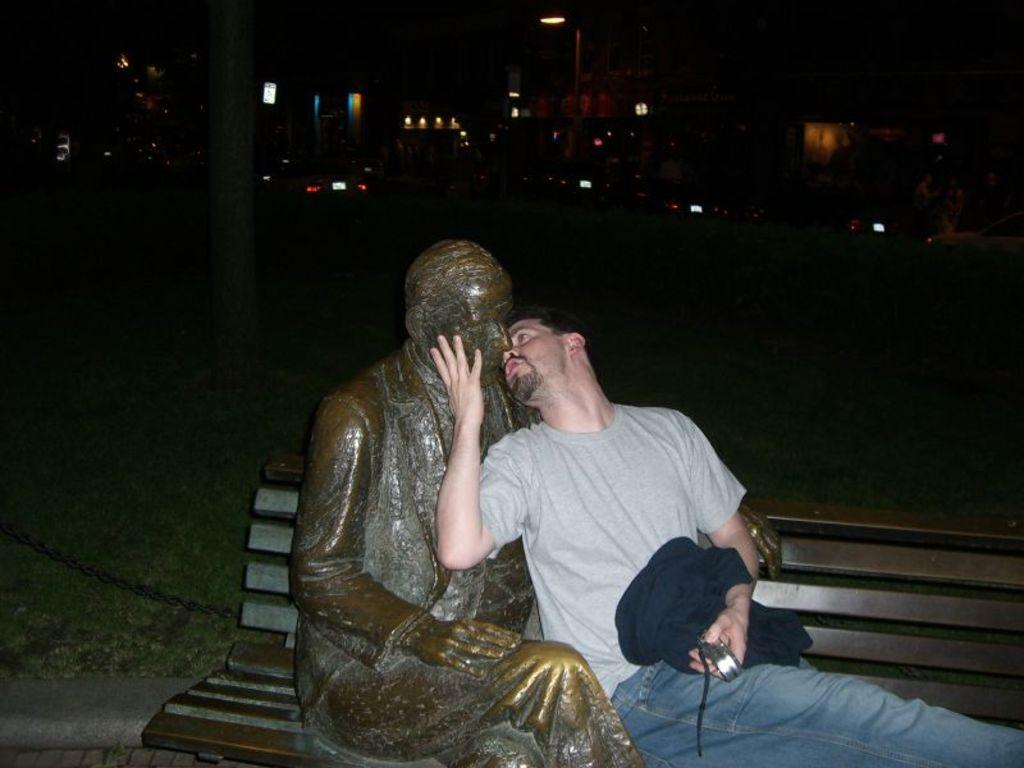What is the person in the image wearing? The person is wearing a grey t-shirt and jeans. What is the person doing in the image? The person is sitting on a bench. What can be seen beside the bench? There is a statue of a man beside the bench. What is visible in the background of the image? Buildings are visible in the background of the image. What type of lighting is present in front of the buildings? Street lights are present in front of the buildings. What type of leather is visible on the roof of the building in the image? There is no leather visible on the roof of the building in the image. 